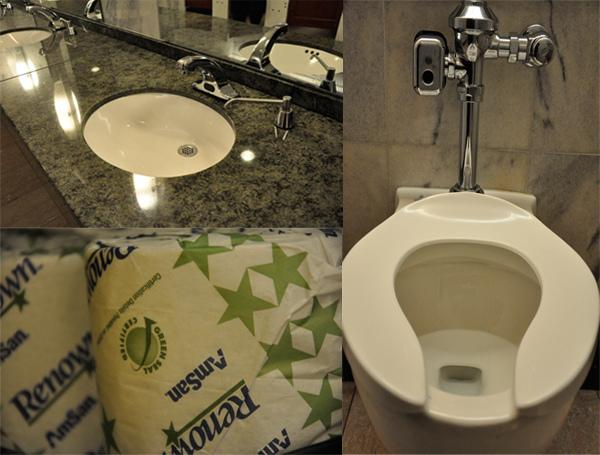How is the toilet flushed? Please explain your reasoning. ir beam. There is no handle to flush it with, so it must use a sensor of some kind. 